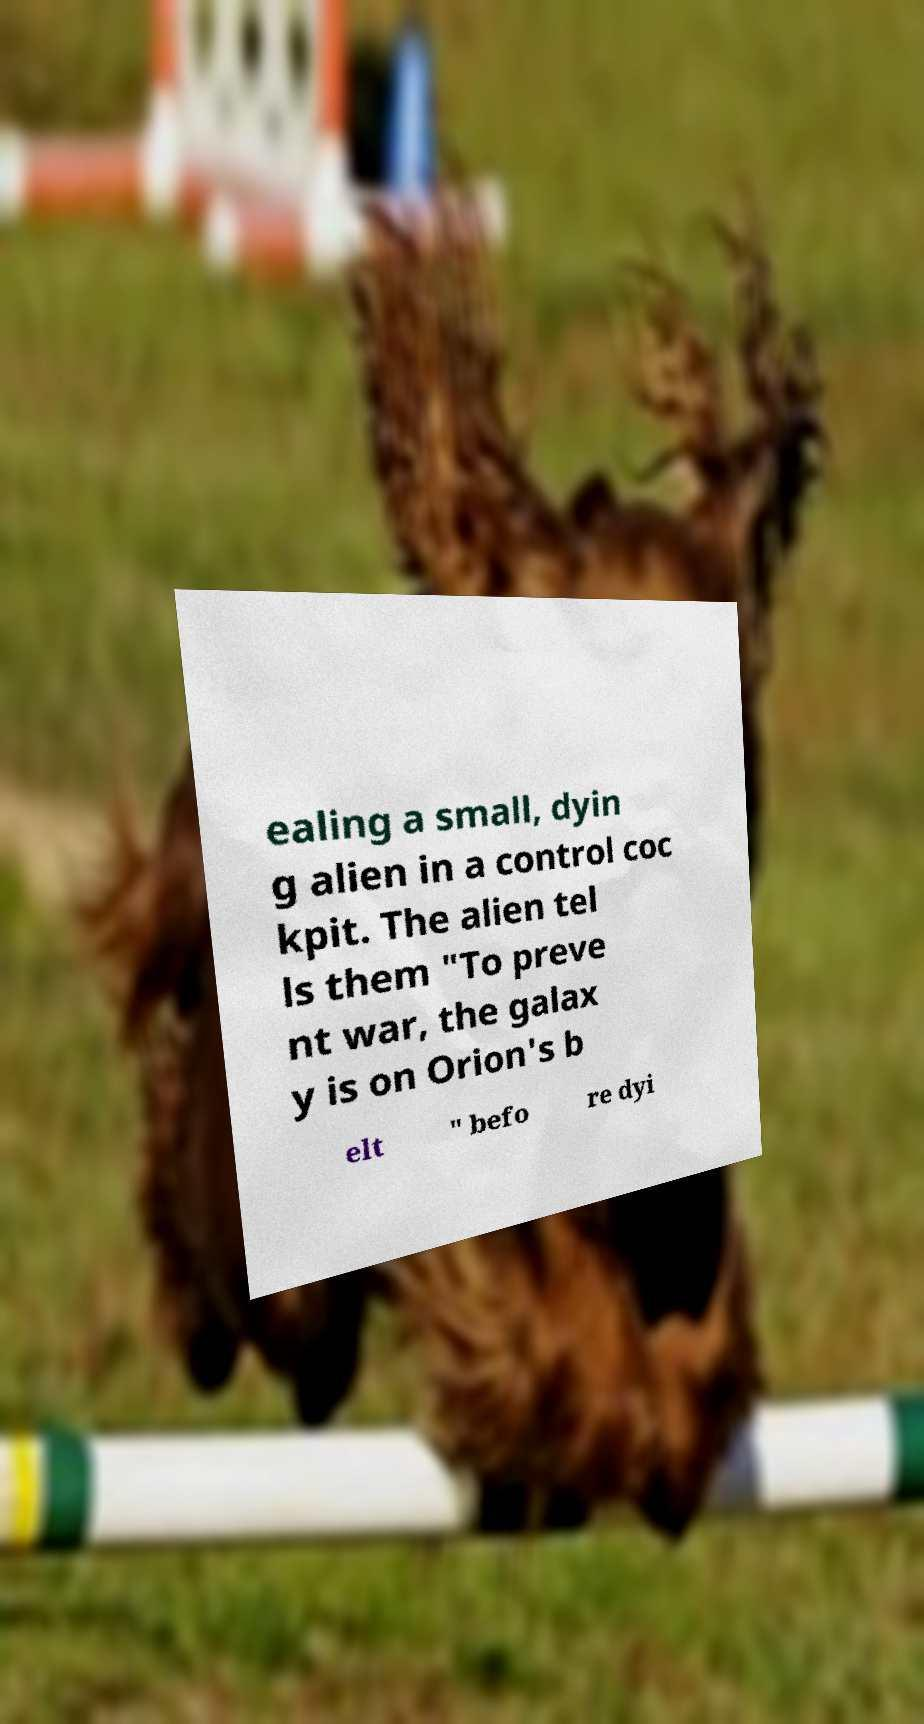I need the written content from this picture converted into text. Can you do that? ealing a small, dyin g alien in a control coc kpit. The alien tel ls them "To preve nt war, the galax y is on Orion's b elt " befo re dyi 